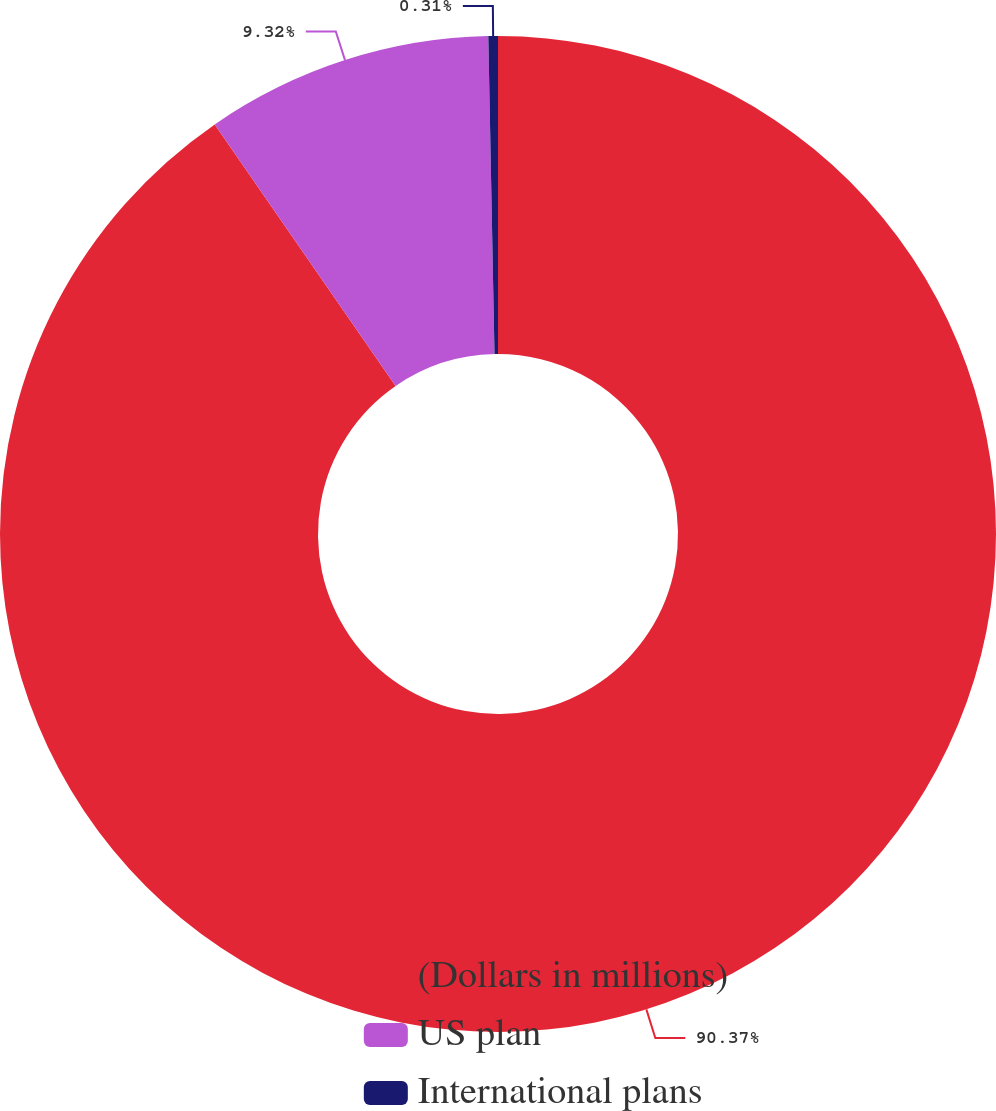<chart> <loc_0><loc_0><loc_500><loc_500><pie_chart><fcel>(Dollars in millions)<fcel>US plan<fcel>International plans<nl><fcel>90.37%<fcel>9.32%<fcel>0.31%<nl></chart> 